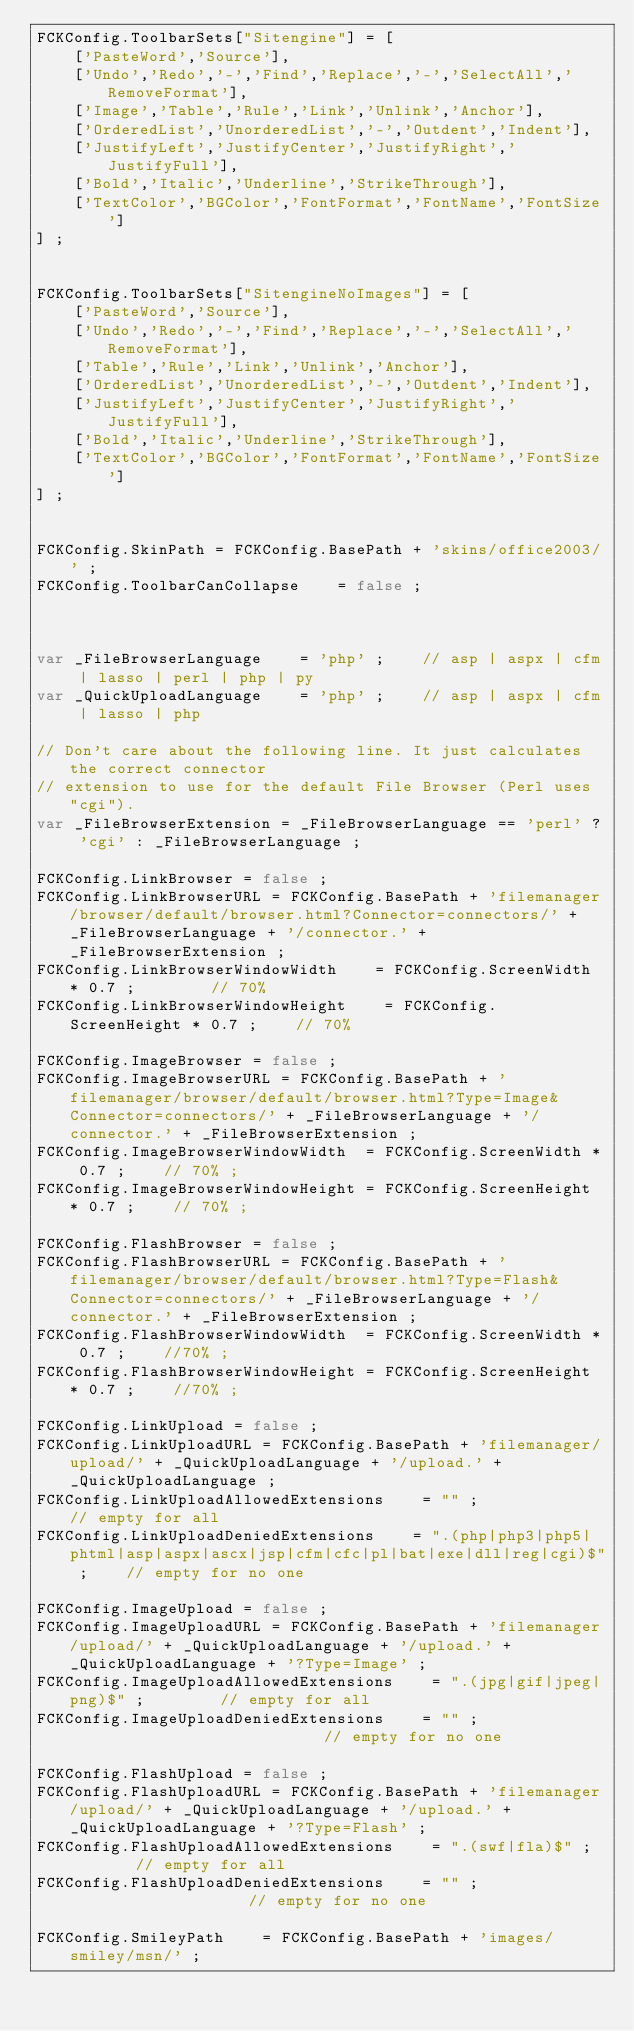<code> <loc_0><loc_0><loc_500><loc_500><_JavaScript_>FCKConfig.ToolbarSets["Sitengine"] = [
    ['PasteWord','Source'],
    ['Undo','Redo','-','Find','Replace','-','SelectAll','RemoveFormat'],
    ['Image','Table','Rule','Link','Unlink','Anchor'],
    ['OrderedList','UnorderedList','-','Outdent','Indent'],
    ['JustifyLeft','JustifyCenter','JustifyRight','JustifyFull'],
    ['Bold','Italic','Underline','StrikeThrough'],
    ['TextColor','BGColor','FontFormat','FontName','FontSize']
] ;


FCKConfig.ToolbarSets["SitengineNoImages"] = [
    ['PasteWord','Source'],
    ['Undo','Redo','-','Find','Replace','-','SelectAll','RemoveFormat'],
    ['Table','Rule','Link','Unlink','Anchor'],
    ['OrderedList','UnorderedList','-','Outdent','Indent'],
    ['JustifyLeft','JustifyCenter','JustifyRight','JustifyFull'],
    ['Bold','Italic','Underline','StrikeThrough'],
    ['TextColor','BGColor','FontFormat','FontName','FontSize']
] ;


FCKConfig.SkinPath = FCKConfig.BasePath + 'skins/office2003/' ;
FCKConfig.ToolbarCanCollapse    = false ;



var _FileBrowserLanguage    = 'php' ;    // asp | aspx | cfm | lasso | perl | php | py
var _QuickUploadLanguage    = 'php' ;    // asp | aspx | cfm | lasso | php

// Don't care about the following line. It just calculates the correct connector 
// extension to use for the default File Browser (Perl uses "cgi").
var _FileBrowserExtension = _FileBrowserLanguage == 'perl' ? 'cgi' : _FileBrowserLanguage ;

FCKConfig.LinkBrowser = false ;
FCKConfig.LinkBrowserURL = FCKConfig.BasePath + 'filemanager/browser/default/browser.html?Connector=connectors/' + _FileBrowserLanguage + '/connector.' + _FileBrowserExtension ;
FCKConfig.LinkBrowserWindowWidth    = FCKConfig.ScreenWidth * 0.7 ;        // 70%
FCKConfig.LinkBrowserWindowHeight    = FCKConfig.ScreenHeight * 0.7 ;    // 70%

FCKConfig.ImageBrowser = false ;
FCKConfig.ImageBrowserURL = FCKConfig.BasePath + 'filemanager/browser/default/browser.html?Type=Image&Connector=connectors/' + _FileBrowserLanguage + '/connector.' + _FileBrowserExtension ;
FCKConfig.ImageBrowserWindowWidth  = FCKConfig.ScreenWidth * 0.7 ;    // 70% ;
FCKConfig.ImageBrowserWindowHeight = FCKConfig.ScreenHeight * 0.7 ;    // 70% ;

FCKConfig.FlashBrowser = false ;
FCKConfig.FlashBrowserURL = FCKConfig.BasePath + 'filemanager/browser/default/browser.html?Type=Flash&Connector=connectors/' + _FileBrowserLanguage + '/connector.' + _FileBrowserExtension ;
FCKConfig.FlashBrowserWindowWidth  = FCKConfig.ScreenWidth * 0.7 ;    //70% ;
FCKConfig.FlashBrowserWindowHeight = FCKConfig.ScreenHeight * 0.7 ;    //70% ;

FCKConfig.LinkUpload = false ;
FCKConfig.LinkUploadURL = FCKConfig.BasePath + 'filemanager/upload/' + _QuickUploadLanguage + '/upload.' + _QuickUploadLanguage ;
FCKConfig.LinkUploadAllowedExtensions    = "" ;            // empty for all
FCKConfig.LinkUploadDeniedExtensions    = ".(php|php3|php5|phtml|asp|aspx|ascx|jsp|cfm|cfc|pl|bat|exe|dll|reg|cgi)$" ;    // empty for no one

FCKConfig.ImageUpload = false ;
FCKConfig.ImageUploadURL = FCKConfig.BasePath + 'filemanager/upload/' + _QuickUploadLanguage + '/upload.' + _QuickUploadLanguage + '?Type=Image' ;
FCKConfig.ImageUploadAllowedExtensions    = ".(jpg|gif|jpeg|png)$" ;        // empty for all
FCKConfig.ImageUploadDeniedExtensions    = "" ;                            // empty for no one

FCKConfig.FlashUpload = false ;
FCKConfig.FlashUploadURL = FCKConfig.BasePath + 'filemanager/upload/' + _QuickUploadLanguage + '/upload.' + _QuickUploadLanguage + '?Type=Flash' ;
FCKConfig.FlashUploadAllowedExtensions    = ".(swf|fla)$" ;        // empty for all
FCKConfig.FlashUploadDeniedExtensions    = "" ;                    // empty for no one

FCKConfig.SmileyPath    = FCKConfig.BasePath + 'images/smiley/msn/' ;</code> 